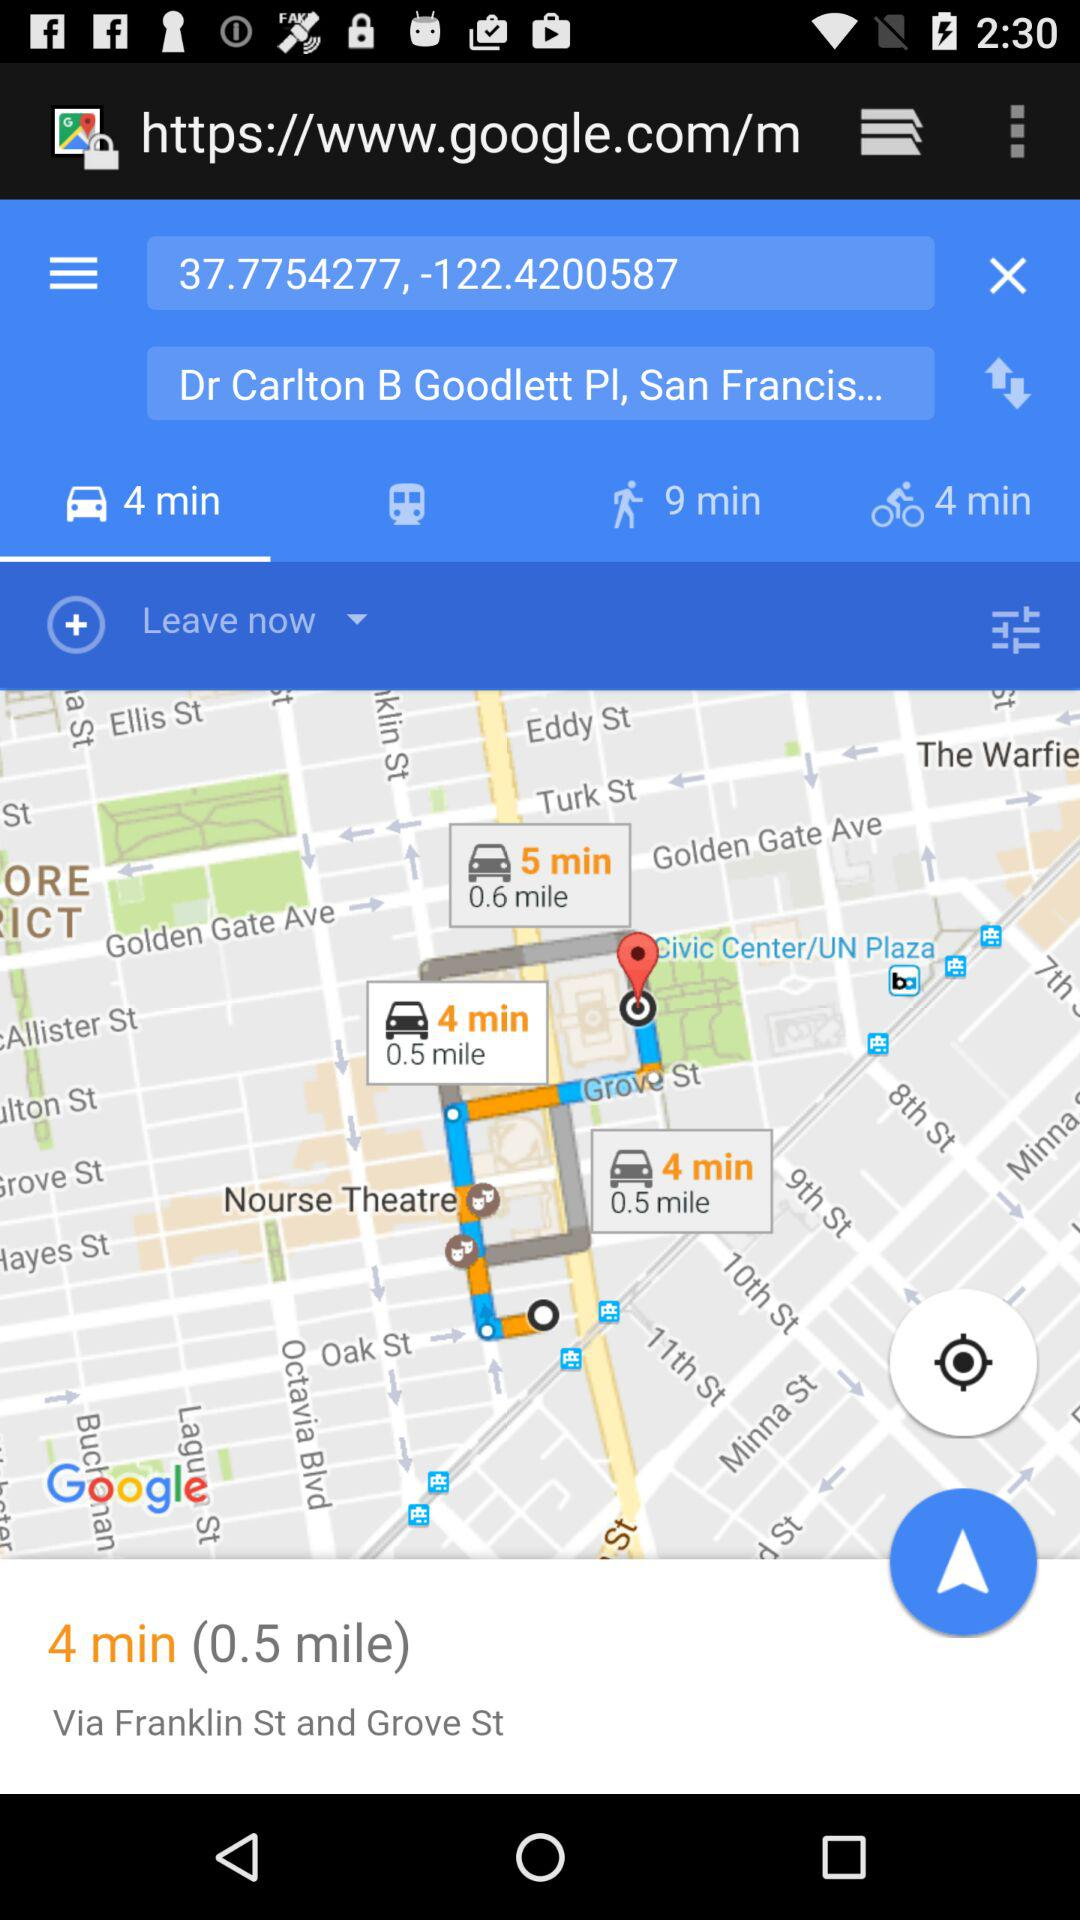What are the coordinates for the starting location? The coordinates are "37.7754277, -122.4200587". 